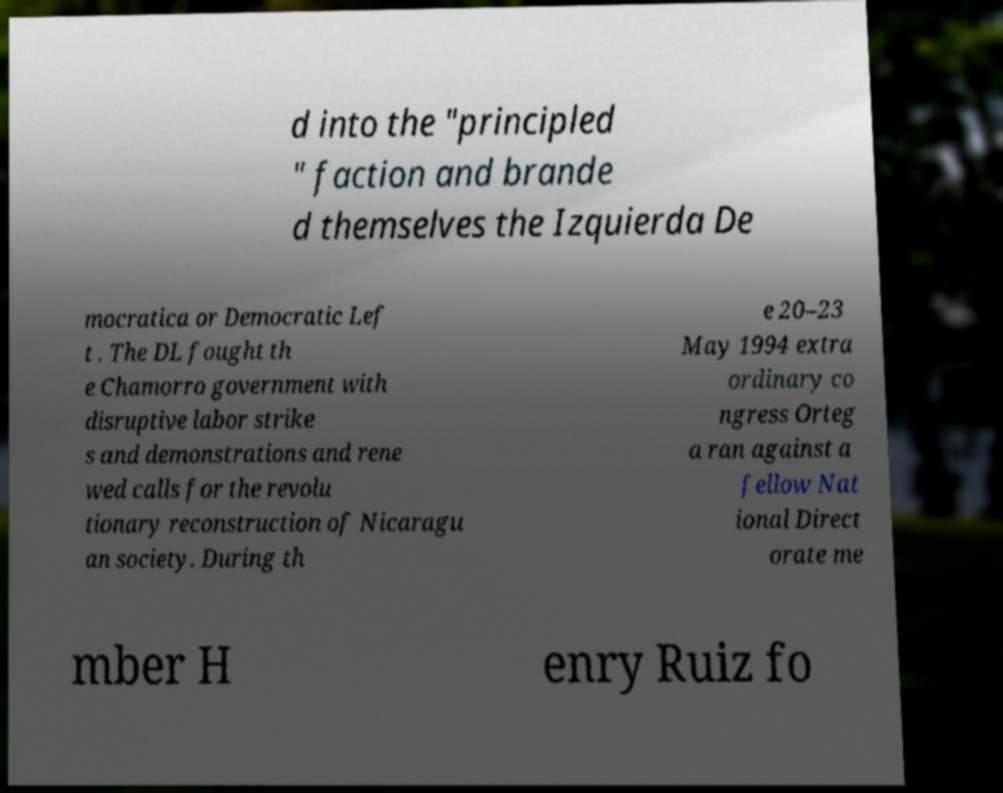Please read and relay the text visible in this image. What does it say? d into the "principled " faction and brande d themselves the Izquierda De mocratica or Democratic Lef t . The DL fought th e Chamorro government with disruptive labor strike s and demonstrations and rene wed calls for the revolu tionary reconstruction of Nicaragu an society. During th e 20–23 May 1994 extra ordinary co ngress Orteg a ran against a fellow Nat ional Direct orate me mber H enry Ruiz fo 